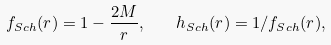Convert formula to latex. <formula><loc_0><loc_0><loc_500><loc_500>f _ { S c h } ( r ) = 1 - \frac { 2 M } { r } , \quad h _ { S c h } ( r ) = 1 / f _ { S c h } ( r ) ,</formula> 